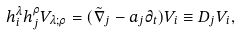<formula> <loc_0><loc_0><loc_500><loc_500>h ^ { \lambda } _ { i } h ^ { \rho } _ { j } V _ { \lambda ; \rho } = ( \tilde { \nabla } _ { j } - a _ { j } \partial _ { t } ) V _ { i } \equiv D _ { j } V _ { i } ,</formula> 